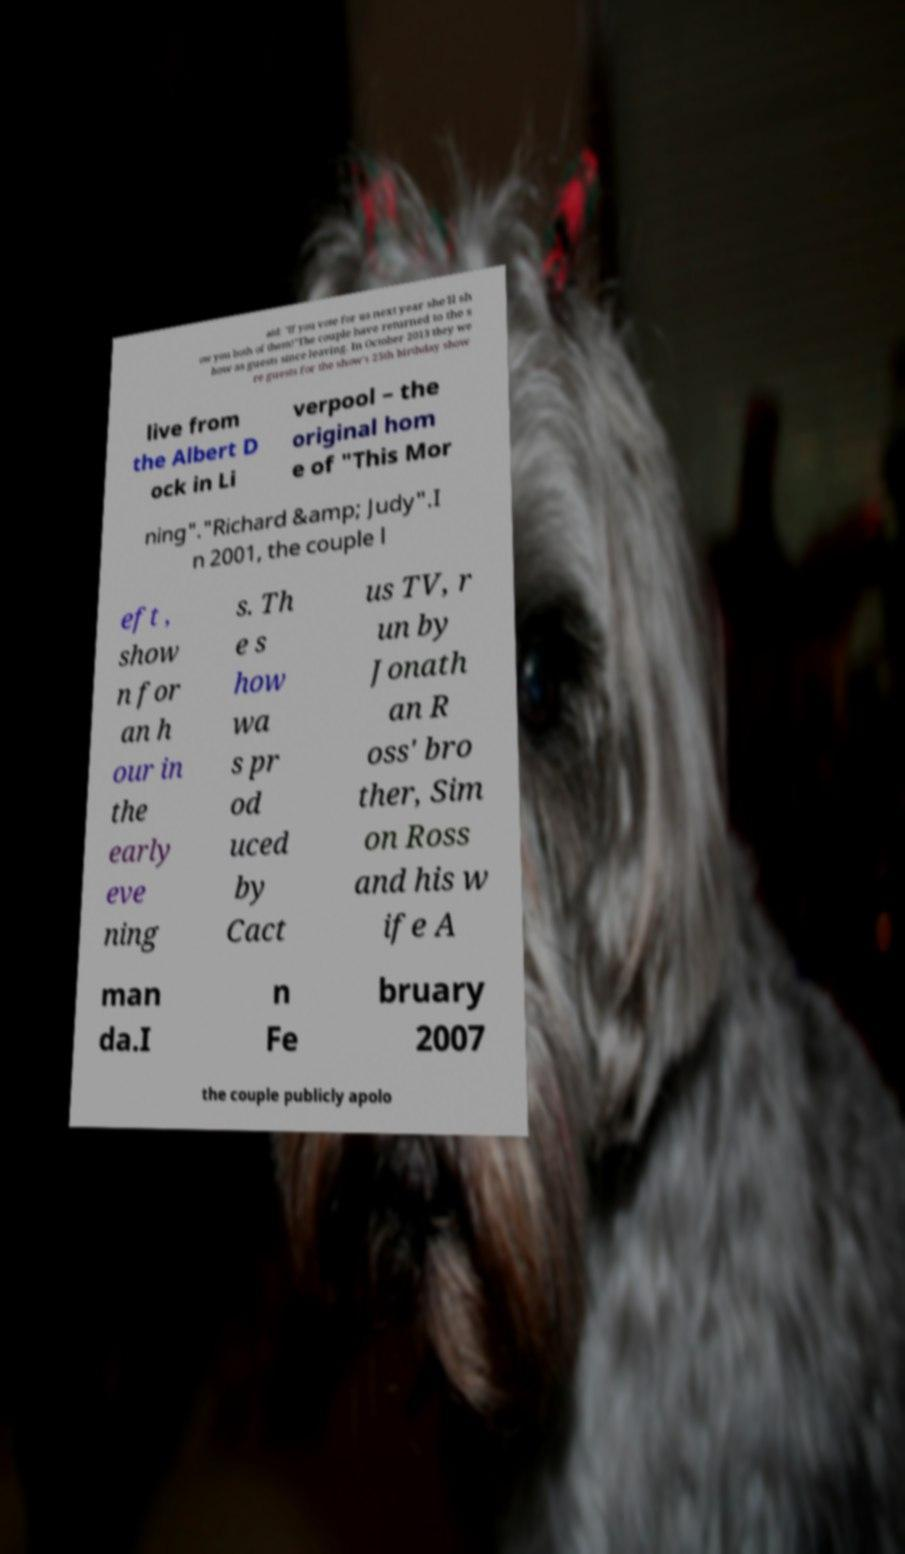Can you accurately transcribe the text from the provided image for me? aid: "If you vote for us next year she'll sh ow you both of them!"The couple have returned to the s how as guests since leaving. In October 2013 they we re guests for the show's 25th birthday show live from the Albert D ock in Li verpool – the original hom e of "This Mor ning"."Richard &amp; Judy".I n 2001, the couple l eft , show n for an h our in the early eve ning s. Th e s how wa s pr od uced by Cact us TV, r un by Jonath an R oss' bro ther, Sim on Ross and his w ife A man da.I n Fe bruary 2007 the couple publicly apolo 